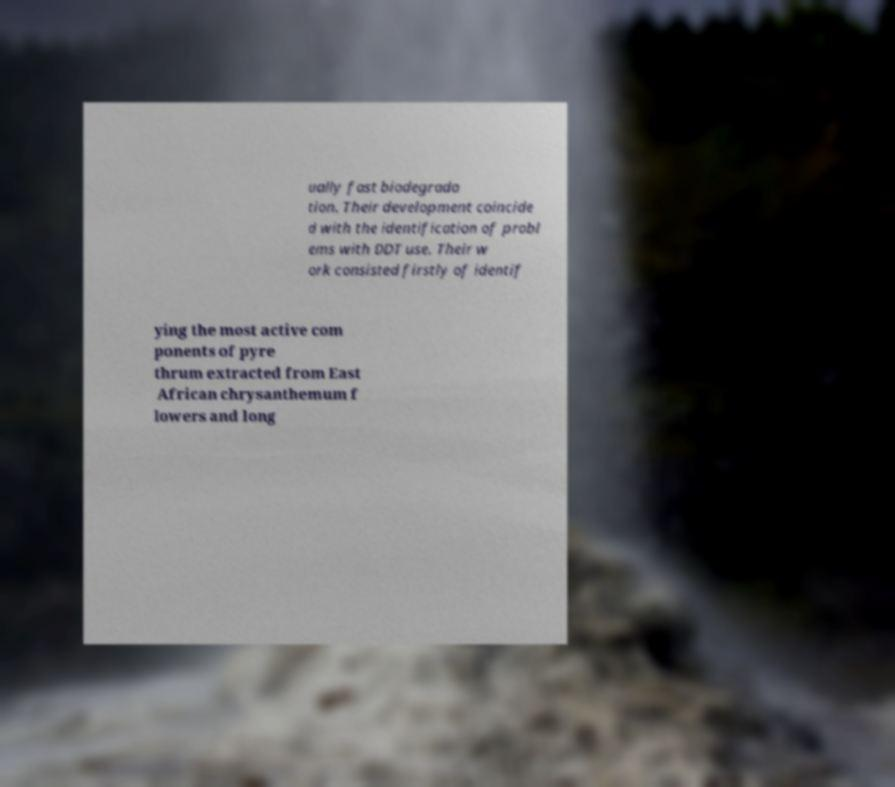Can you accurately transcribe the text from the provided image for me? ually fast biodegrada tion. Their development coincide d with the identification of probl ems with DDT use. Their w ork consisted firstly of identif ying the most active com ponents of pyre thrum extracted from East African chrysanthemum f lowers and long 